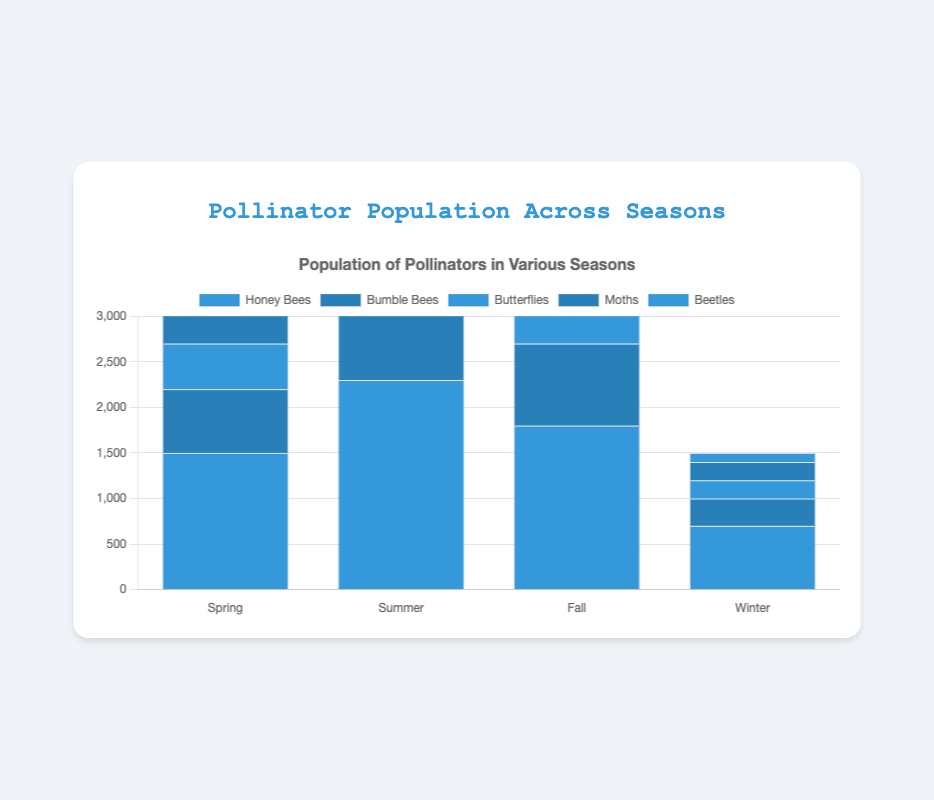How does the population of Honey Bees in Summer compare to Fall? Observing the bar heights, the Honey Bee population in Summer is 2300, which is higher than in Fall, which is 1800.
Answer: Honey Bee population is higher in Summer Which season has the highest number of Bumble Bees? By comparing the bar heights for Bumble Bees across all seasons, Summer has the highest population at 1200.
Answer: Summer What is the combined population of Butterflies and Moths in Spring? Summing the individual populations: Butterflies (500) + Moths (600) = 1100.
Answer: 1100 During which season do Beetles have the lowest population, and what is that population? Comparing the Beetle bars, Winter has the lowest population at 100.
Answer: Winter, 100 What's the total population of all pollinators in Winter? Summing the populations: Honey Bees (700) + Bumble Bees (300) + Butterflies (200) + Moths (200) + Beetles (100) = 1500.
Answer: 1500 Which pollinator shows the greatest population decrease from Summer to Fall? The largest decrease is Honey Bees, dropping from 2300 in Summer to 1800 in Fall, a decrease of 500.
Answer: Honey Bees Are there more Bumble Bees or Moths in Fall? Comparing the bar heights for Fall, Bumble Bees are at 900 and Moths at 650.
Answer: Bumble Bees What is the average population of Butterflies across all seasons? Sum the populations: 500 (Spring) + 1400 (Summer) + 800 (Fall) + 200 (Winter) = 2900, then divide by 4 seasons: 2900 / 4 = 725.
Answer: 725 How does the population of Butterflies in Summer compare to their population in Winter? The bar for Butterflies shows 1400 in Summer and 200 in Winter, indicating a higher population in Summer.
Answer: Higher in Summer Which seasons have a higher pollinator population of Moths than Butterflies? Spring (Moths: 600 vs Butterflies: 500) and Winter (Moths: 200 vs Butterflies: 200, which is equal). Other seasons When: Moths have lower or equal populations than Butterflies.
Answer: Spring 